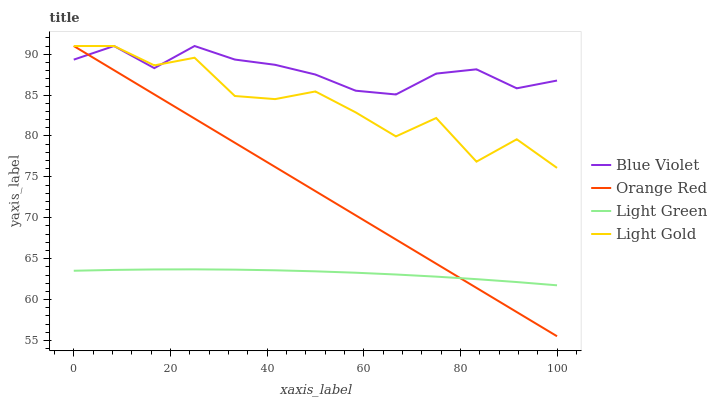Does Light Green have the minimum area under the curve?
Answer yes or no. Yes. Does Blue Violet have the maximum area under the curve?
Answer yes or no. Yes. Does Light Gold have the minimum area under the curve?
Answer yes or no. No. Does Light Gold have the maximum area under the curve?
Answer yes or no. No. Is Orange Red the smoothest?
Answer yes or no. Yes. Is Light Gold the roughest?
Answer yes or no. Yes. Is Light Gold the smoothest?
Answer yes or no. No. Is Orange Red the roughest?
Answer yes or no. No. Does Orange Red have the lowest value?
Answer yes or no. Yes. Does Light Gold have the lowest value?
Answer yes or no. No. Does Blue Violet have the highest value?
Answer yes or no. Yes. Is Light Green less than Blue Violet?
Answer yes or no. Yes. Is Blue Violet greater than Light Green?
Answer yes or no. Yes. Does Orange Red intersect Blue Violet?
Answer yes or no. Yes. Is Orange Red less than Blue Violet?
Answer yes or no. No. Is Orange Red greater than Blue Violet?
Answer yes or no. No. Does Light Green intersect Blue Violet?
Answer yes or no. No. 